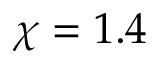Convert formula to latex. <formula><loc_0><loc_0><loc_500><loc_500>\chi = 1 . 4</formula> 